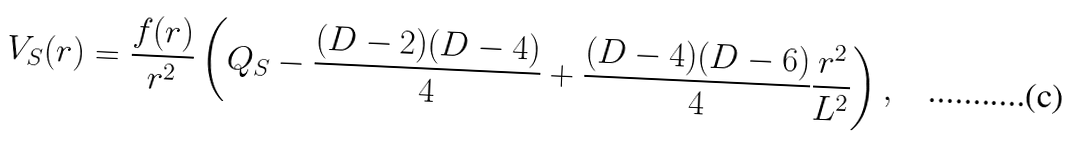<formula> <loc_0><loc_0><loc_500><loc_500>V _ { S } ( r ) = \frac { f ( r ) } { r ^ { 2 } } \left ( Q _ { S } - \frac { ( D - 2 ) ( D - 4 ) } { 4 } + \frac { ( D - 4 ) ( D - 6 ) } { 4 } \frac { r ^ { 2 } } { L ^ { 2 } } \right ) ,</formula> 